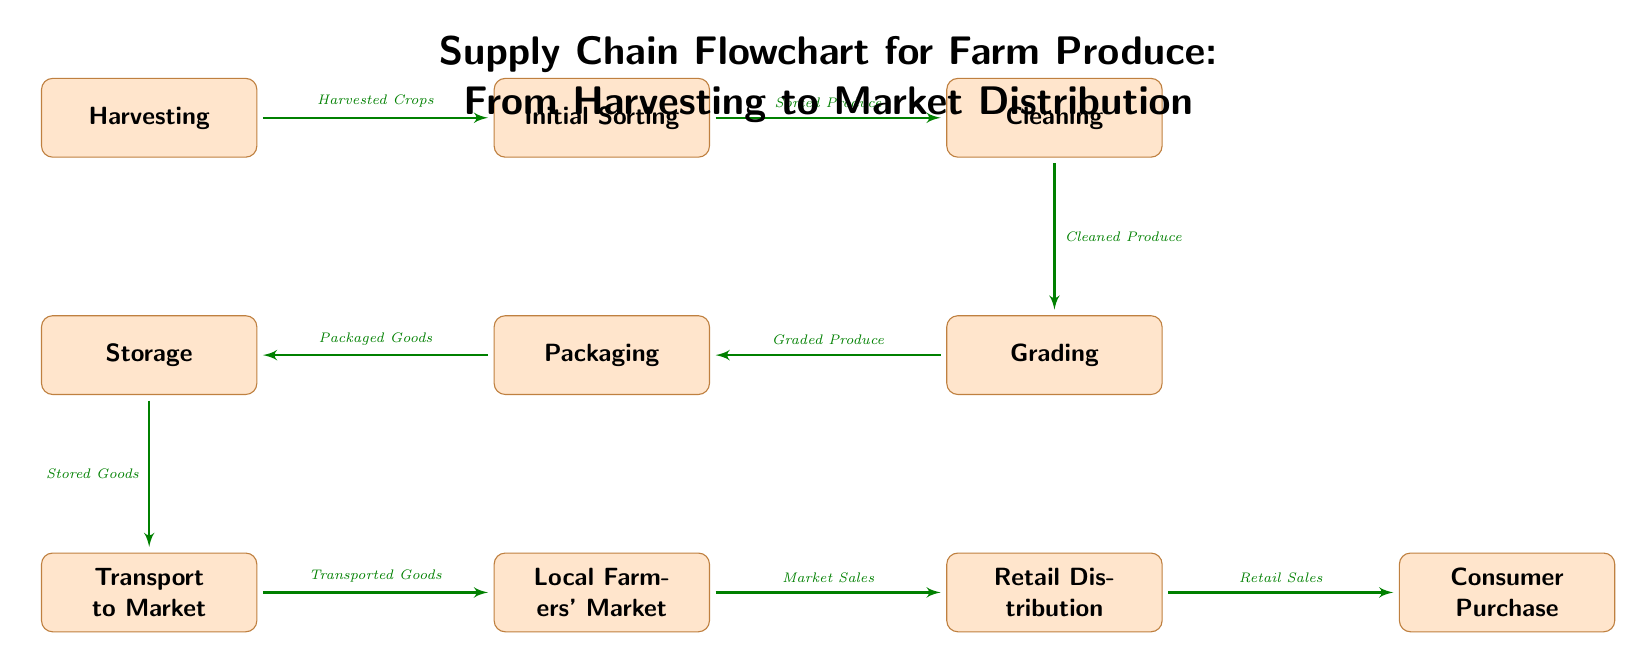What is the first stage in the supply chain? The first stage shown in the flowchart is labeled as "Harvesting," which indicates the starting point of the supply chain for farm produce.
Answer: Harvesting How many nodes are in the diagram? The diagram contains a total of ten nodes, each representing distinct stages or processes in the supply chain.
Answer: 10 What is the final stage in the supply chain? The final stage in the flowchart is labeled as "Consumer Purchase," indicating where consumers buy the produce.
Answer: Consumer Purchase Which stage immediately follows "Cleaning"? The stage that immediately follows "Cleaning" is "Grading," as indicated by the arrows connecting the nodes in the flowchart.
Answer: Grading What type of goods come from the "Packaging" stage? The goods that result from the "Packaging" stage are referred to as "Packaged Goods," which are a product of that process in the supply chain.
Answer: Packaged Goods Which two stages connect directly to the "Storage" stage? The two stages that connect directly to the "Storage" stage are "Packaging" feeding into it, and "Transport to Market" coming out of it. This means Storage handles the goods that come from Packaging before they are transported to market.
Answer: Packaging, Transport to Market What is the relationship between "Initial Sorting" and "Cleaning"? The relationship is that "Initial Sorting" leads to the "Cleaning" stage, as produce is sorted first and then cleaned in the sequence of the supply chain flowchart.
Answer: Sorted Produce Which stage is linked to the "Local Farmers' Market"? The "Transport to Market" stage is linked to "Local Farmers' Market," meaning goods are transported from storage to this market location.
Answer: Transport to Market How are products sold at the end of the supply chain? Products are sold to consumers at the final stage, identified in the diagram as "Consumer Purchase," indicating the completion of the market distribution process.
Answer: Retail Sales 